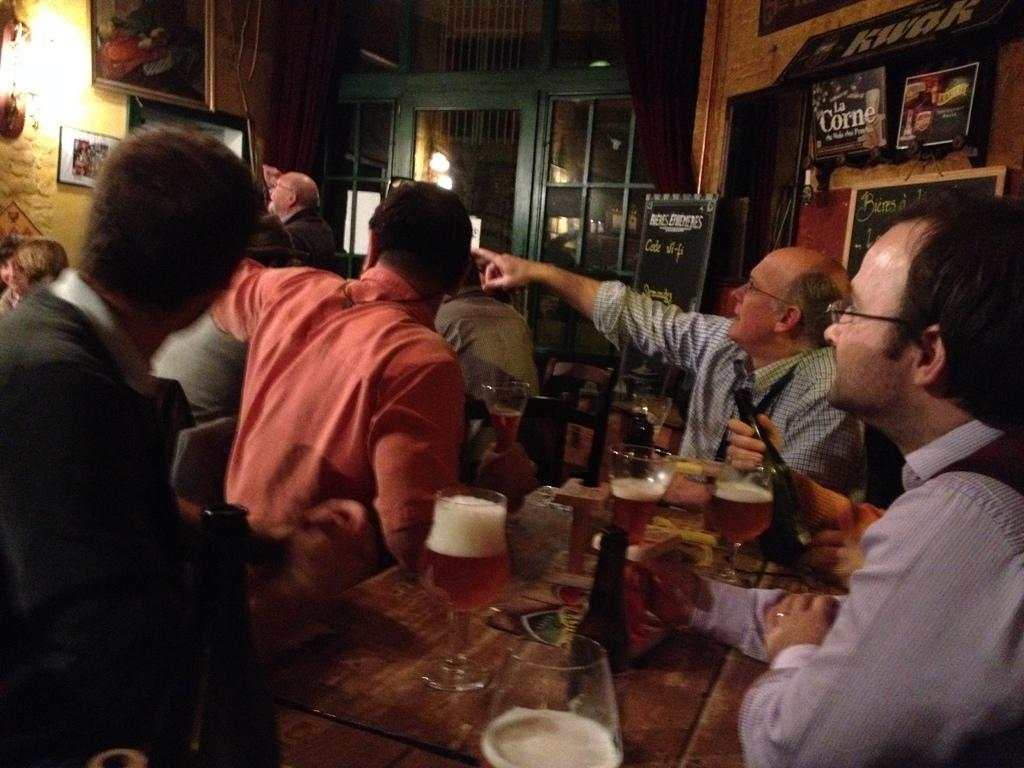What are the people in the image doing? The people in the image are sitting on chairs. What objects can be seen on the table? There are glasses and bottles on the table. Can you describe the actions of the person holding a bottle? A person is holding a bottle in the image. What can be seen in the background of the image? There is a wall in the background, with frames on it, and a light. What type of fowl can be seen flying in the image? There is no fowl or flight present in the image; it features people sitting on chairs, glasses, bottles, a wall, frames, and a light. 